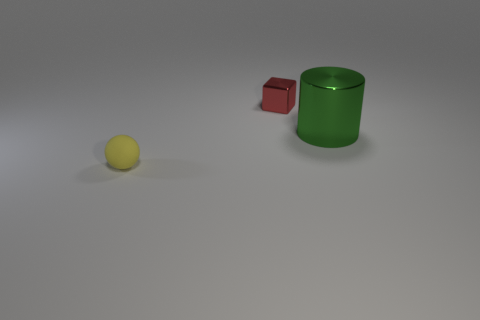Add 2 cubes. How many objects exist? 5 Subtract all red cylinders. Subtract all gray cubes. How many cylinders are left? 1 Subtract all brown cylinders. How many yellow cubes are left? 0 Subtract all tiny red rubber spheres. Subtract all large cylinders. How many objects are left? 2 Add 1 small red shiny blocks. How many small red shiny blocks are left? 2 Add 1 matte spheres. How many matte spheres exist? 2 Subtract 1 yellow spheres. How many objects are left? 2 